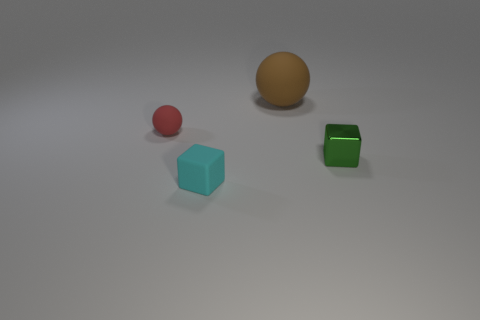What material is the green object that is the same shape as the small cyan matte thing?
Offer a very short reply. Metal. How many things are small things that are to the right of the small red rubber ball or matte balls to the left of the cyan block?
Provide a short and direct response. 3. There is a object in front of the green cube; is its shape the same as the small thing to the right of the brown object?
Make the answer very short. Yes. There is a green metal thing that is the same size as the red rubber object; what shape is it?
Keep it short and to the point. Cube. What number of shiny objects are either tiny red spheres or tiny blue cylinders?
Offer a very short reply. 0. Do the cube to the left of the green block and the object on the right side of the large matte thing have the same material?
Offer a very short reply. No. The tiny block that is the same material as the brown ball is what color?
Your response must be concise. Cyan. Are there more tiny rubber things to the right of the brown matte ball than large spheres to the right of the green block?
Provide a succinct answer. No. Are there any large green balls?
Offer a very short reply. No. How many things are big red matte balls or cubes?
Make the answer very short. 2. 